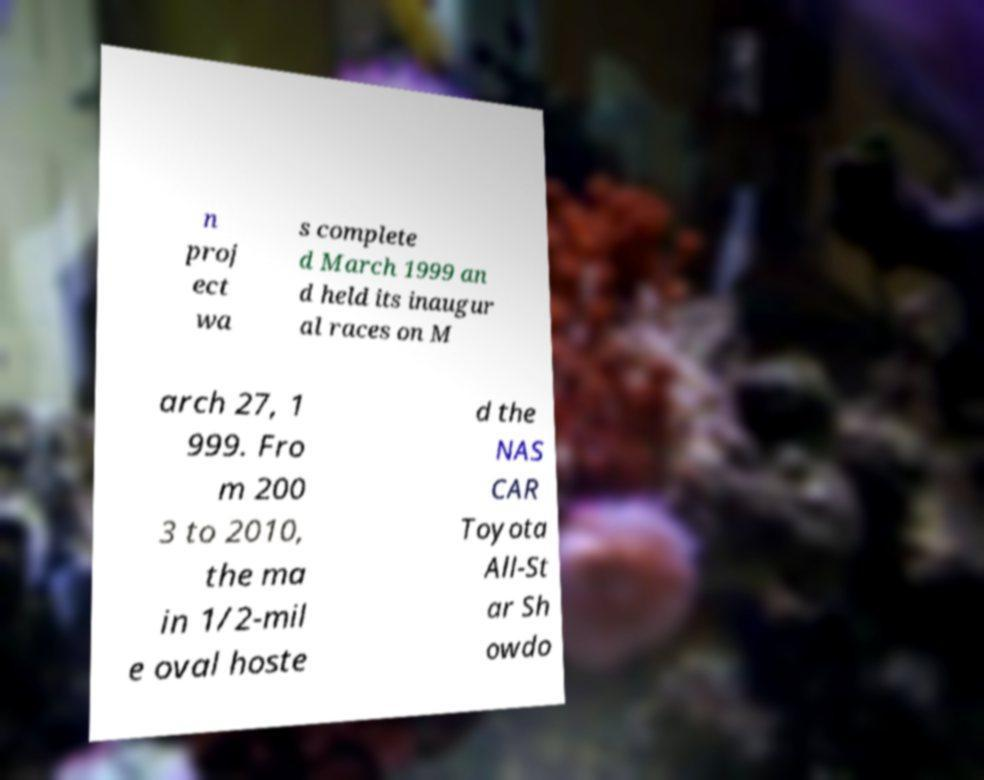Please identify and transcribe the text found in this image. n proj ect wa s complete d March 1999 an d held its inaugur al races on M arch 27, 1 999. Fro m 200 3 to 2010, the ma in 1/2-mil e oval hoste d the NAS CAR Toyota All-St ar Sh owdo 